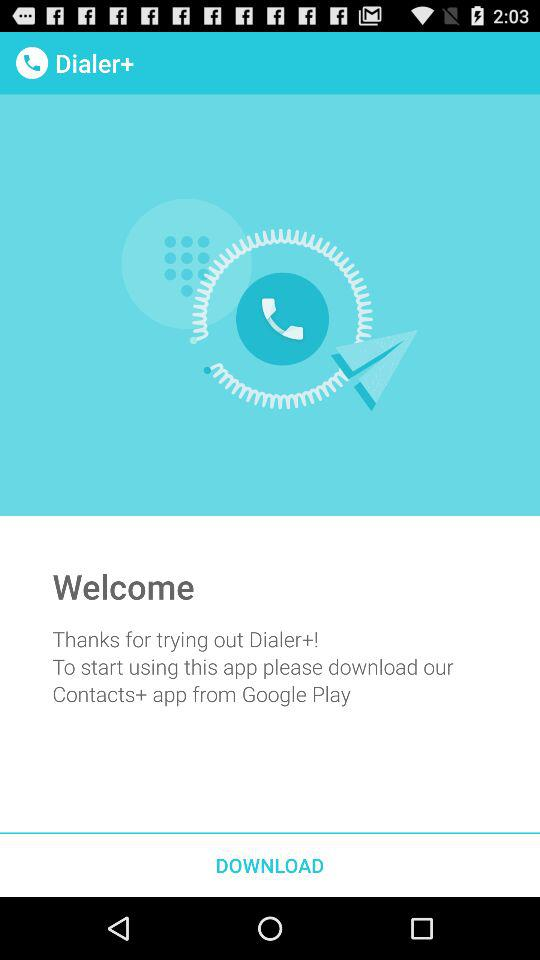Which application should I download to start using the "Dialer+" application? You should download the "Contacts+" application to start using the "Dialer+" application. 